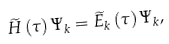Convert formula to latex. <formula><loc_0><loc_0><loc_500><loc_500>\widetilde { H } \left ( \tau \right ) \Psi _ { k } = \widetilde { E } _ { k } \left ( \tau \right ) \Psi _ { k } ,</formula> 